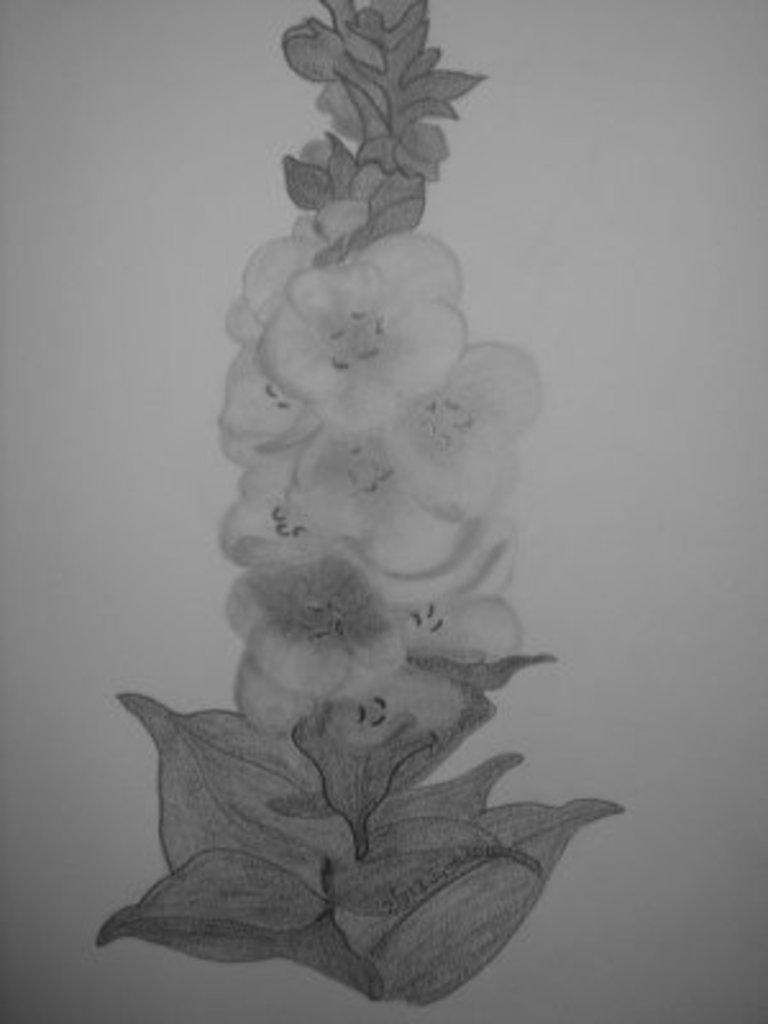Please provide a concise description of this image. As we can see in the image there is a paper. On paper there is plant drawing. 